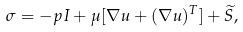<formula> <loc_0><loc_0><loc_500><loc_500>\sigma = - p I + \mu [ \nabla u + ( \nabla u ) ^ { T } ] + \widetilde { S } ,</formula> 